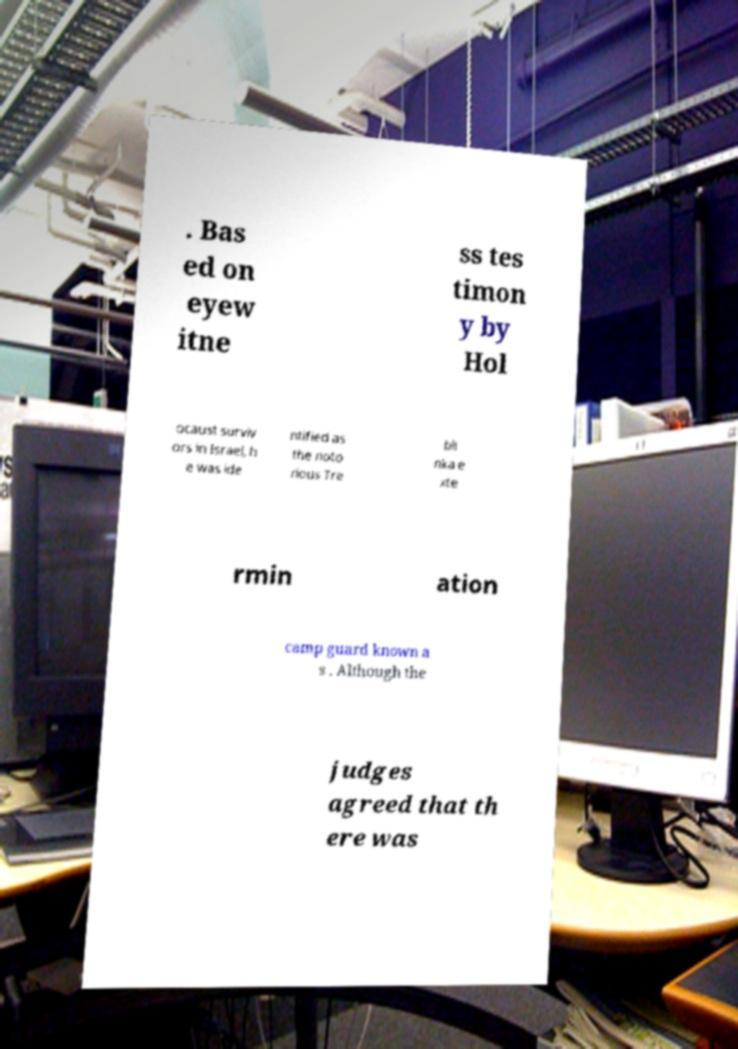Please identify and transcribe the text found in this image. . Bas ed on eyew itne ss tes timon y by Hol ocaust surviv ors in Israel, h e was ide ntified as the noto rious Tre bli nka e xte rmin ation camp guard known a s . Although the judges agreed that th ere was 